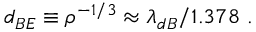Convert formula to latex. <formula><loc_0><loc_0><loc_500><loc_500>d _ { B E } \equiv \rho ^ { - 1 / 3 } \approx \lambda _ { d B } / 1 . 3 7 8 \ .</formula> 